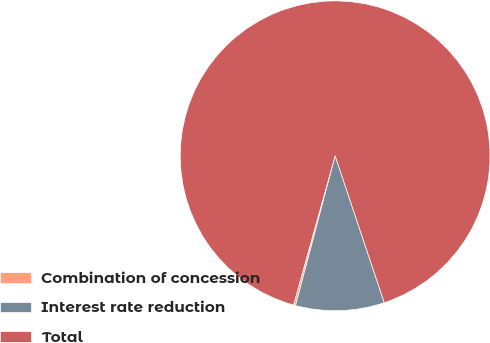<chart> <loc_0><loc_0><loc_500><loc_500><pie_chart><fcel>Combination of concession<fcel>Interest rate reduction<fcel>Total<nl><fcel>0.22%<fcel>9.25%<fcel>90.53%<nl></chart> 